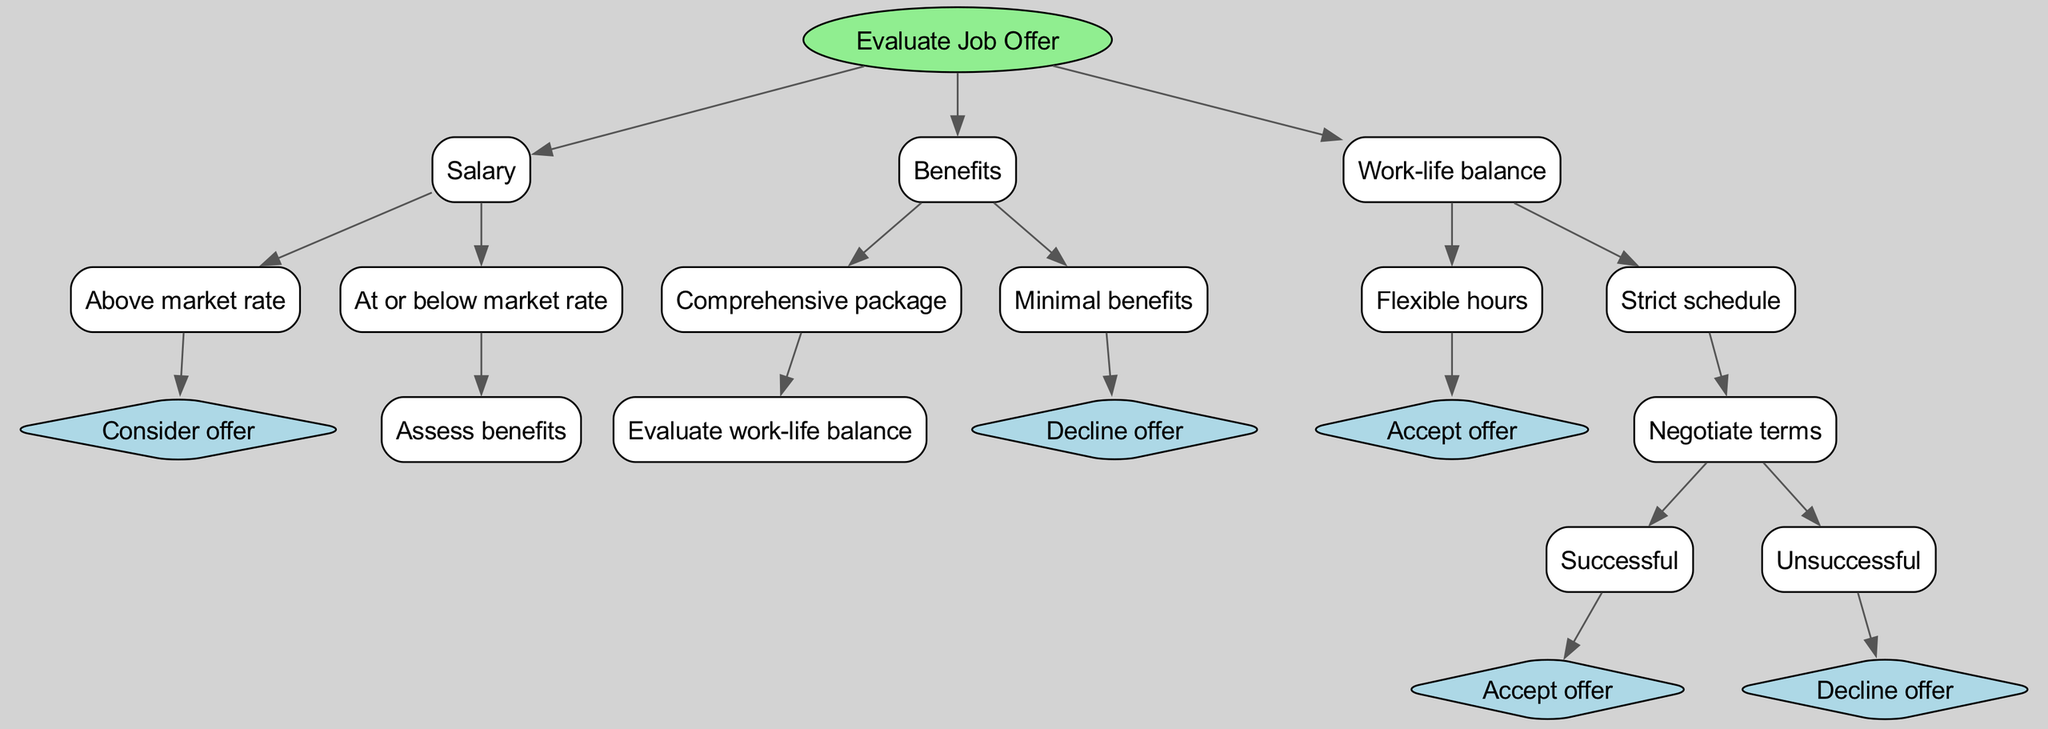What is the root of the decision tree? The root of the decision tree is "Evaluate Job Offer." It is the topmost node from which all other nodes branch out.
Answer: Evaluate Job Offer How many primary nodes are there under the root? There are three primary nodes under the root: "Salary," "Benefits," and "Work-life balance." These represent the main categories considered in the evaluation.
Answer: 3 What happens if the salary is at or below market rate? If the salary is at or below market rate, the next step is to "Assess benefits," meaning that the decision process will move to evaluating the benefits.
Answer: Assess benefits What decision is made if the benefits are minimal? If the benefits are minimal, the decision made is to "Decline offer," indicating that the offer is not favorable based on that criterion.
Answer: Decline offer What is the outcome if the work-life balance is flexible hours? If the work-life balance allows for flexible hours, the outcome is to "Accept offer," which means the job is deemed satisfactory based on this aspect.
Answer: Accept offer What decision follows if the work-life balance has a strict schedule and the negotiation is unsuccessful? If the work-life balance has a strict schedule and negotiation is unsuccessful, the decision is to "Decline offer," reflecting that the conditions were not acceptable.
Answer: Decline offer What do you need to evaluate if the salary is above the market rate? If the salary is above the market rate, the next step is to "Consider offer," indicating that this is a favorable condition to potentially accept the job.
Answer: Consider offer What is the consequence of negotiating successfully after having a strict schedule? If negotiations are successful after a strict schedule, the consequence is to "Accept offer," indicating that the terms of employment were improved.
Answer: Accept offer What type of node is "Decline offer"? "Decline offer" is a decision node, as it represents a definitive decision made based on the evaluation process.
Answer: Decision node 